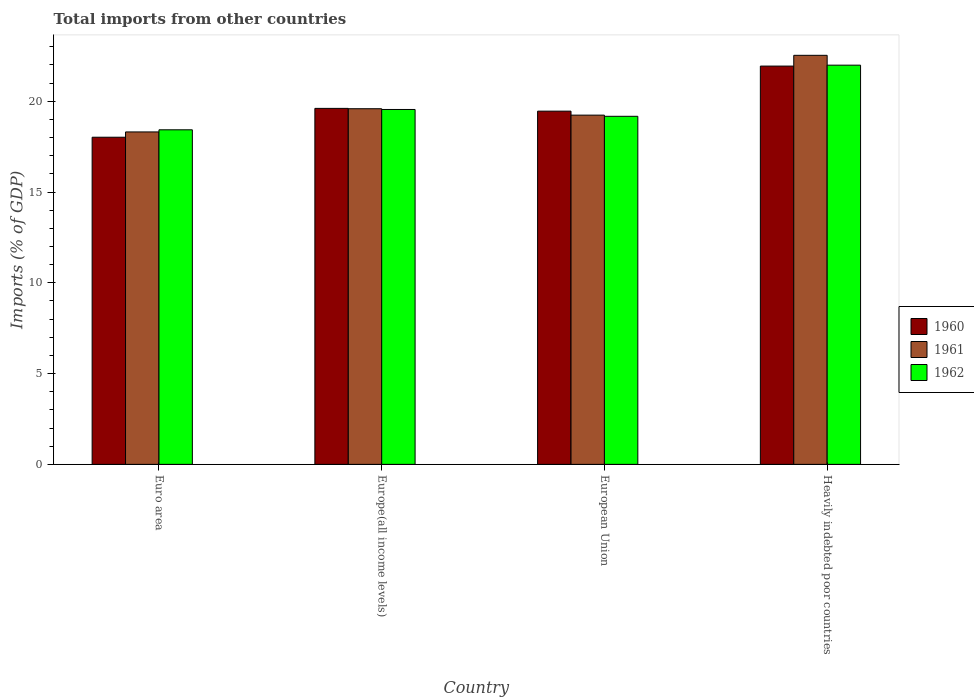Are the number of bars per tick equal to the number of legend labels?
Ensure brevity in your answer.  Yes. Are the number of bars on each tick of the X-axis equal?
Ensure brevity in your answer.  Yes. How many bars are there on the 1st tick from the right?
Keep it short and to the point. 3. What is the label of the 4th group of bars from the left?
Offer a very short reply. Heavily indebted poor countries. What is the total imports in 1960 in Euro area?
Your answer should be very brief. 18.02. Across all countries, what is the maximum total imports in 1961?
Your answer should be very brief. 22.53. Across all countries, what is the minimum total imports in 1961?
Provide a short and direct response. 18.31. In which country was the total imports in 1961 maximum?
Ensure brevity in your answer.  Heavily indebted poor countries. In which country was the total imports in 1962 minimum?
Offer a very short reply. Euro area. What is the total total imports in 1962 in the graph?
Your answer should be very brief. 79.14. What is the difference between the total imports in 1961 in European Union and that in Heavily indebted poor countries?
Offer a very short reply. -3.29. What is the difference between the total imports in 1960 in Euro area and the total imports in 1962 in Heavily indebted poor countries?
Make the answer very short. -3.97. What is the average total imports in 1962 per country?
Give a very brief answer. 19.79. What is the difference between the total imports of/in 1961 and total imports of/in 1962 in Heavily indebted poor countries?
Provide a succinct answer. 0.54. What is the ratio of the total imports in 1960 in Euro area to that in Europe(all income levels)?
Your response must be concise. 0.92. What is the difference between the highest and the second highest total imports in 1960?
Make the answer very short. -0.15. What is the difference between the highest and the lowest total imports in 1962?
Provide a short and direct response. 3.56. What does the 2nd bar from the right in Euro area represents?
Provide a succinct answer. 1961. Is it the case that in every country, the sum of the total imports in 1962 and total imports in 1960 is greater than the total imports in 1961?
Make the answer very short. Yes. How many bars are there?
Provide a short and direct response. 12. How many countries are there in the graph?
Offer a very short reply. 4. Are the values on the major ticks of Y-axis written in scientific E-notation?
Your response must be concise. No. Does the graph contain any zero values?
Make the answer very short. No. Does the graph contain grids?
Your answer should be very brief. No. Where does the legend appear in the graph?
Your response must be concise. Center right. What is the title of the graph?
Make the answer very short. Total imports from other countries. What is the label or title of the X-axis?
Your answer should be very brief. Country. What is the label or title of the Y-axis?
Your answer should be very brief. Imports (% of GDP). What is the Imports (% of GDP) in 1960 in Euro area?
Make the answer very short. 18.02. What is the Imports (% of GDP) in 1961 in Euro area?
Offer a terse response. 18.31. What is the Imports (% of GDP) of 1962 in Euro area?
Give a very brief answer. 18.43. What is the Imports (% of GDP) in 1960 in Europe(all income levels)?
Give a very brief answer. 19.61. What is the Imports (% of GDP) in 1961 in Europe(all income levels)?
Keep it short and to the point. 19.59. What is the Imports (% of GDP) in 1962 in Europe(all income levels)?
Offer a terse response. 19.55. What is the Imports (% of GDP) in 1960 in European Union?
Provide a succinct answer. 19.46. What is the Imports (% of GDP) of 1961 in European Union?
Ensure brevity in your answer.  19.24. What is the Imports (% of GDP) in 1962 in European Union?
Provide a succinct answer. 19.17. What is the Imports (% of GDP) of 1960 in Heavily indebted poor countries?
Provide a succinct answer. 21.94. What is the Imports (% of GDP) of 1961 in Heavily indebted poor countries?
Offer a very short reply. 22.53. What is the Imports (% of GDP) in 1962 in Heavily indebted poor countries?
Make the answer very short. 21.99. Across all countries, what is the maximum Imports (% of GDP) in 1960?
Provide a short and direct response. 21.94. Across all countries, what is the maximum Imports (% of GDP) in 1961?
Keep it short and to the point. 22.53. Across all countries, what is the maximum Imports (% of GDP) of 1962?
Provide a short and direct response. 21.99. Across all countries, what is the minimum Imports (% of GDP) of 1960?
Offer a terse response. 18.02. Across all countries, what is the minimum Imports (% of GDP) in 1961?
Keep it short and to the point. 18.31. Across all countries, what is the minimum Imports (% of GDP) of 1962?
Offer a very short reply. 18.43. What is the total Imports (% of GDP) in 1960 in the graph?
Your response must be concise. 79.03. What is the total Imports (% of GDP) of 1961 in the graph?
Give a very brief answer. 79.67. What is the total Imports (% of GDP) in 1962 in the graph?
Ensure brevity in your answer.  79.14. What is the difference between the Imports (% of GDP) of 1960 in Euro area and that in Europe(all income levels)?
Your response must be concise. -1.59. What is the difference between the Imports (% of GDP) in 1961 in Euro area and that in Europe(all income levels)?
Your answer should be compact. -1.28. What is the difference between the Imports (% of GDP) of 1962 in Euro area and that in Europe(all income levels)?
Your answer should be very brief. -1.12. What is the difference between the Imports (% of GDP) in 1960 in Euro area and that in European Union?
Provide a succinct answer. -1.44. What is the difference between the Imports (% of GDP) in 1961 in Euro area and that in European Union?
Make the answer very short. -0.93. What is the difference between the Imports (% of GDP) in 1962 in Euro area and that in European Union?
Your response must be concise. -0.74. What is the difference between the Imports (% of GDP) of 1960 in Euro area and that in Heavily indebted poor countries?
Your response must be concise. -3.92. What is the difference between the Imports (% of GDP) in 1961 in Euro area and that in Heavily indebted poor countries?
Provide a succinct answer. -4.22. What is the difference between the Imports (% of GDP) in 1962 in Euro area and that in Heavily indebted poor countries?
Provide a succinct answer. -3.56. What is the difference between the Imports (% of GDP) in 1960 in Europe(all income levels) and that in European Union?
Ensure brevity in your answer.  0.15. What is the difference between the Imports (% of GDP) of 1961 in Europe(all income levels) and that in European Union?
Provide a succinct answer. 0.35. What is the difference between the Imports (% of GDP) in 1962 in Europe(all income levels) and that in European Union?
Your answer should be compact. 0.38. What is the difference between the Imports (% of GDP) in 1960 in Europe(all income levels) and that in Heavily indebted poor countries?
Offer a terse response. -2.33. What is the difference between the Imports (% of GDP) of 1961 in Europe(all income levels) and that in Heavily indebted poor countries?
Offer a terse response. -2.94. What is the difference between the Imports (% of GDP) in 1962 in Europe(all income levels) and that in Heavily indebted poor countries?
Offer a very short reply. -2.44. What is the difference between the Imports (% of GDP) in 1960 in European Union and that in Heavily indebted poor countries?
Offer a terse response. -2.48. What is the difference between the Imports (% of GDP) in 1961 in European Union and that in Heavily indebted poor countries?
Give a very brief answer. -3.29. What is the difference between the Imports (% of GDP) in 1962 in European Union and that in Heavily indebted poor countries?
Provide a short and direct response. -2.82. What is the difference between the Imports (% of GDP) in 1960 in Euro area and the Imports (% of GDP) in 1961 in Europe(all income levels)?
Offer a very short reply. -1.57. What is the difference between the Imports (% of GDP) in 1960 in Euro area and the Imports (% of GDP) in 1962 in Europe(all income levels)?
Your answer should be very brief. -1.53. What is the difference between the Imports (% of GDP) of 1961 in Euro area and the Imports (% of GDP) of 1962 in Europe(all income levels)?
Keep it short and to the point. -1.24. What is the difference between the Imports (% of GDP) in 1960 in Euro area and the Imports (% of GDP) in 1961 in European Union?
Your answer should be very brief. -1.22. What is the difference between the Imports (% of GDP) of 1960 in Euro area and the Imports (% of GDP) of 1962 in European Union?
Keep it short and to the point. -1.15. What is the difference between the Imports (% of GDP) of 1961 in Euro area and the Imports (% of GDP) of 1962 in European Union?
Offer a terse response. -0.86. What is the difference between the Imports (% of GDP) of 1960 in Euro area and the Imports (% of GDP) of 1961 in Heavily indebted poor countries?
Keep it short and to the point. -4.51. What is the difference between the Imports (% of GDP) of 1960 in Euro area and the Imports (% of GDP) of 1962 in Heavily indebted poor countries?
Your response must be concise. -3.97. What is the difference between the Imports (% of GDP) in 1961 in Euro area and the Imports (% of GDP) in 1962 in Heavily indebted poor countries?
Offer a terse response. -3.68. What is the difference between the Imports (% of GDP) of 1960 in Europe(all income levels) and the Imports (% of GDP) of 1961 in European Union?
Give a very brief answer. 0.37. What is the difference between the Imports (% of GDP) of 1960 in Europe(all income levels) and the Imports (% of GDP) of 1962 in European Union?
Offer a terse response. 0.44. What is the difference between the Imports (% of GDP) in 1961 in Europe(all income levels) and the Imports (% of GDP) in 1962 in European Union?
Provide a short and direct response. 0.42. What is the difference between the Imports (% of GDP) in 1960 in Europe(all income levels) and the Imports (% of GDP) in 1961 in Heavily indebted poor countries?
Make the answer very short. -2.92. What is the difference between the Imports (% of GDP) in 1960 in Europe(all income levels) and the Imports (% of GDP) in 1962 in Heavily indebted poor countries?
Make the answer very short. -2.38. What is the difference between the Imports (% of GDP) of 1961 in Europe(all income levels) and the Imports (% of GDP) of 1962 in Heavily indebted poor countries?
Your answer should be compact. -2.4. What is the difference between the Imports (% of GDP) of 1960 in European Union and the Imports (% of GDP) of 1961 in Heavily indebted poor countries?
Make the answer very short. -3.08. What is the difference between the Imports (% of GDP) in 1960 in European Union and the Imports (% of GDP) in 1962 in Heavily indebted poor countries?
Keep it short and to the point. -2.53. What is the difference between the Imports (% of GDP) in 1961 in European Union and the Imports (% of GDP) in 1962 in Heavily indebted poor countries?
Your answer should be very brief. -2.75. What is the average Imports (% of GDP) in 1960 per country?
Offer a very short reply. 19.76. What is the average Imports (% of GDP) of 1961 per country?
Your answer should be compact. 19.92. What is the average Imports (% of GDP) in 1962 per country?
Ensure brevity in your answer.  19.79. What is the difference between the Imports (% of GDP) in 1960 and Imports (% of GDP) in 1961 in Euro area?
Give a very brief answer. -0.29. What is the difference between the Imports (% of GDP) in 1960 and Imports (% of GDP) in 1962 in Euro area?
Your answer should be compact. -0.41. What is the difference between the Imports (% of GDP) of 1961 and Imports (% of GDP) of 1962 in Euro area?
Offer a very short reply. -0.12. What is the difference between the Imports (% of GDP) in 1960 and Imports (% of GDP) in 1961 in Europe(all income levels)?
Your answer should be very brief. 0.02. What is the difference between the Imports (% of GDP) of 1960 and Imports (% of GDP) of 1962 in Europe(all income levels)?
Offer a very short reply. 0.06. What is the difference between the Imports (% of GDP) of 1961 and Imports (% of GDP) of 1962 in Europe(all income levels)?
Your answer should be very brief. 0.04. What is the difference between the Imports (% of GDP) of 1960 and Imports (% of GDP) of 1961 in European Union?
Your answer should be compact. 0.22. What is the difference between the Imports (% of GDP) of 1960 and Imports (% of GDP) of 1962 in European Union?
Offer a very short reply. 0.28. What is the difference between the Imports (% of GDP) in 1961 and Imports (% of GDP) in 1962 in European Union?
Keep it short and to the point. 0.07. What is the difference between the Imports (% of GDP) in 1960 and Imports (% of GDP) in 1961 in Heavily indebted poor countries?
Provide a short and direct response. -0.59. What is the difference between the Imports (% of GDP) in 1960 and Imports (% of GDP) in 1962 in Heavily indebted poor countries?
Your answer should be compact. -0.05. What is the difference between the Imports (% of GDP) of 1961 and Imports (% of GDP) of 1962 in Heavily indebted poor countries?
Your answer should be very brief. 0.54. What is the ratio of the Imports (% of GDP) in 1960 in Euro area to that in Europe(all income levels)?
Ensure brevity in your answer.  0.92. What is the ratio of the Imports (% of GDP) of 1961 in Euro area to that in Europe(all income levels)?
Your response must be concise. 0.93. What is the ratio of the Imports (% of GDP) in 1962 in Euro area to that in Europe(all income levels)?
Keep it short and to the point. 0.94. What is the ratio of the Imports (% of GDP) of 1960 in Euro area to that in European Union?
Your answer should be very brief. 0.93. What is the ratio of the Imports (% of GDP) of 1961 in Euro area to that in European Union?
Provide a succinct answer. 0.95. What is the ratio of the Imports (% of GDP) of 1962 in Euro area to that in European Union?
Make the answer very short. 0.96. What is the ratio of the Imports (% of GDP) of 1960 in Euro area to that in Heavily indebted poor countries?
Provide a succinct answer. 0.82. What is the ratio of the Imports (% of GDP) in 1961 in Euro area to that in Heavily indebted poor countries?
Offer a terse response. 0.81. What is the ratio of the Imports (% of GDP) in 1962 in Euro area to that in Heavily indebted poor countries?
Keep it short and to the point. 0.84. What is the ratio of the Imports (% of GDP) in 1960 in Europe(all income levels) to that in European Union?
Make the answer very short. 1.01. What is the ratio of the Imports (% of GDP) of 1961 in Europe(all income levels) to that in European Union?
Your answer should be compact. 1.02. What is the ratio of the Imports (% of GDP) of 1962 in Europe(all income levels) to that in European Union?
Keep it short and to the point. 1.02. What is the ratio of the Imports (% of GDP) in 1960 in Europe(all income levels) to that in Heavily indebted poor countries?
Your answer should be very brief. 0.89. What is the ratio of the Imports (% of GDP) of 1961 in Europe(all income levels) to that in Heavily indebted poor countries?
Give a very brief answer. 0.87. What is the ratio of the Imports (% of GDP) of 1962 in Europe(all income levels) to that in Heavily indebted poor countries?
Your response must be concise. 0.89. What is the ratio of the Imports (% of GDP) in 1960 in European Union to that in Heavily indebted poor countries?
Make the answer very short. 0.89. What is the ratio of the Imports (% of GDP) in 1961 in European Union to that in Heavily indebted poor countries?
Provide a succinct answer. 0.85. What is the ratio of the Imports (% of GDP) in 1962 in European Union to that in Heavily indebted poor countries?
Your answer should be very brief. 0.87. What is the difference between the highest and the second highest Imports (% of GDP) of 1960?
Offer a terse response. 2.33. What is the difference between the highest and the second highest Imports (% of GDP) in 1961?
Offer a terse response. 2.94. What is the difference between the highest and the second highest Imports (% of GDP) in 1962?
Provide a succinct answer. 2.44. What is the difference between the highest and the lowest Imports (% of GDP) of 1960?
Make the answer very short. 3.92. What is the difference between the highest and the lowest Imports (% of GDP) of 1961?
Make the answer very short. 4.22. What is the difference between the highest and the lowest Imports (% of GDP) of 1962?
Provide a succinct answer. 3.56. 